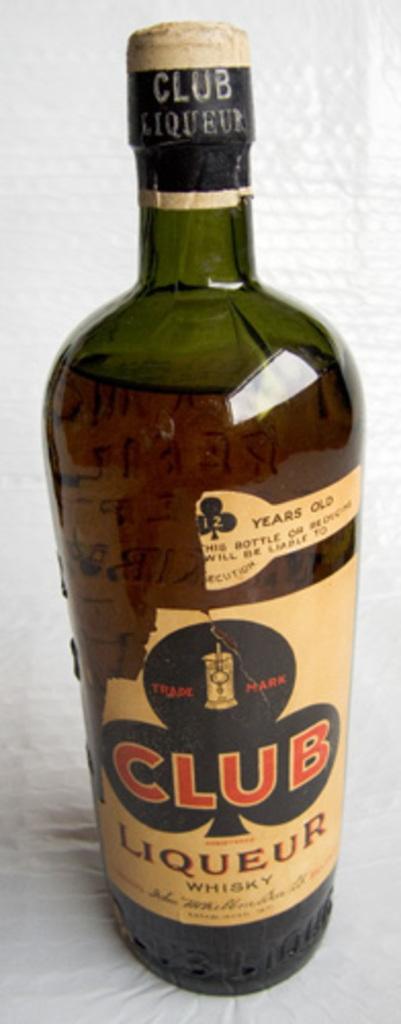What type of liqueur is it?
Your response must be concise. Club. What four letter word can clearly be read in the center of this whisky liqueur label?
Provide a succinct answer. Club. 